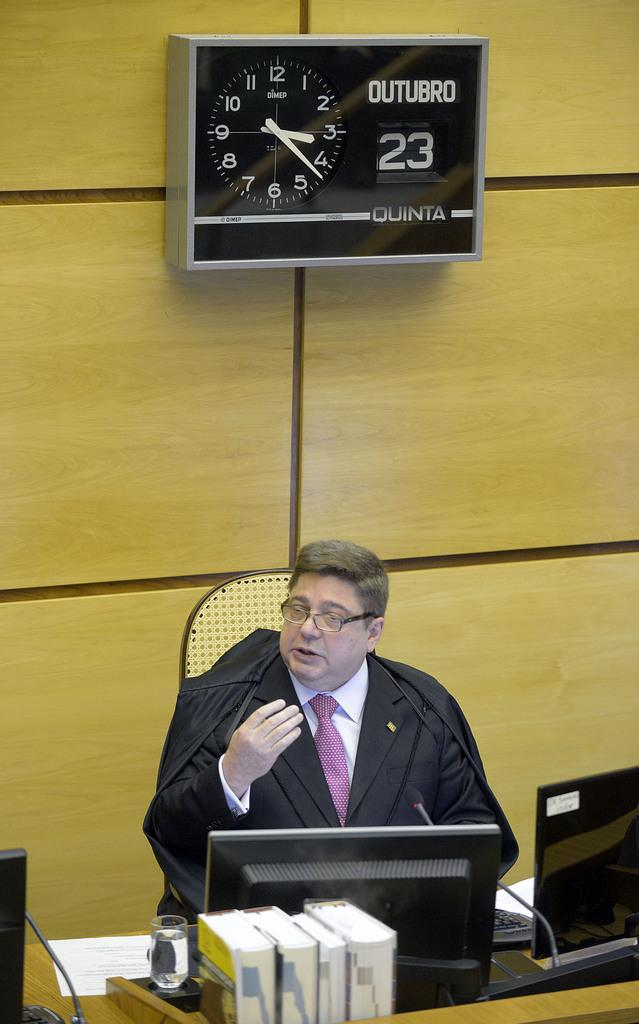<image>
Create a compact narrative representing the image presented. A man speaks from behind a desk and the time is 3:22. 